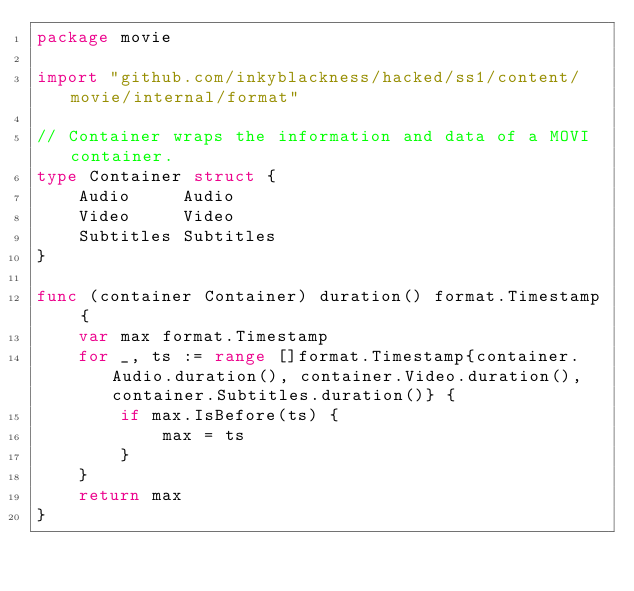Convert code to text. <code><loc_0><loc_0><loc_500><loc_500><_Go_>package movie

import "github.com/inkyblackness/hacked/ss1/content/movie/internal/format"

// Container wraps the information and data of a MOVI container.
type Container struct {
	Audio     Audio
	Video     Video
	Subtitles Subtitles
}

func (container Container) duration() format.Timestamp {
	var max format.Timestamp
	for _, ts := range []format.Timestamp{container.Audio.duration(), container.Video.duration(), container.Subtitles.duration()} {
		if max.IsBefore(ts) {
			max = ts
		}
	}
	return max
}
</code> 